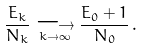Convert formula to latex. <formula><loc_0><loc_0><loc_500><loc_500>\frac { E _ { k } } { N _ { k } } \underset { k \rightarrow \infty } { \longrightarrow } \frac { E _ { 0 } + 1 } { N _ { 0 } } \, .</formula> 